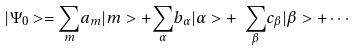<formula> <loc_0><loc_0><loc_500><loc_500>| \Psi _ { 0 } > = { \sum _ { m } } a _ { m } | m > + { \sum _ { \alpha } } b _ { \alpha } | \alpha > + { \ \sum _ { \beta } } c _ { \beta } | \beta > + \cdots</formula> 